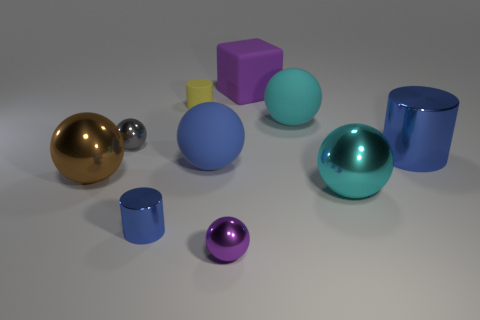What is the color of the other metal thing that is the same shape as the big blue shiny object? The object sharing the same spherical shape as the large blue sphere is golden in color. It's reflecting light in a way that highlights its polished, metallic surface, giving it a rich, warm hue. 